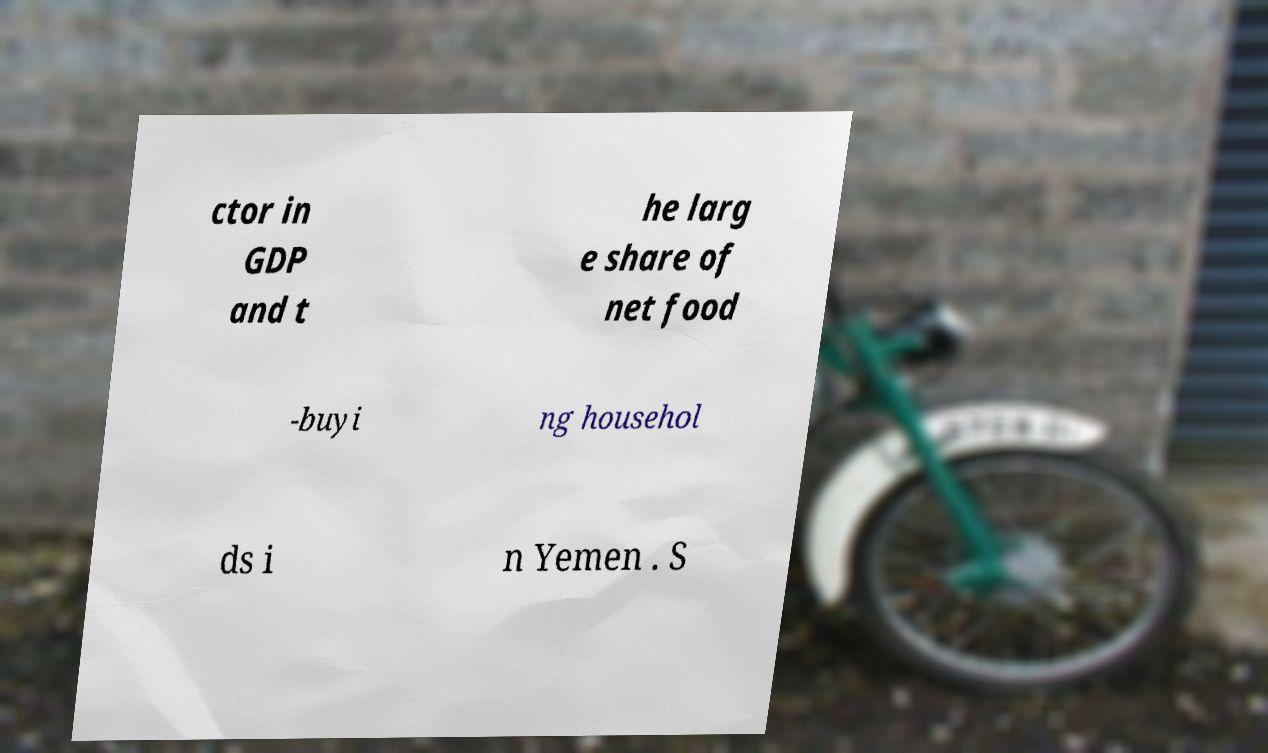There's text embedded in this image that I need extracted. Can you transcribe it verbatim? ctor in GDP and t he larg e share of net food -buyi ng househol ds i n Yemen . S 